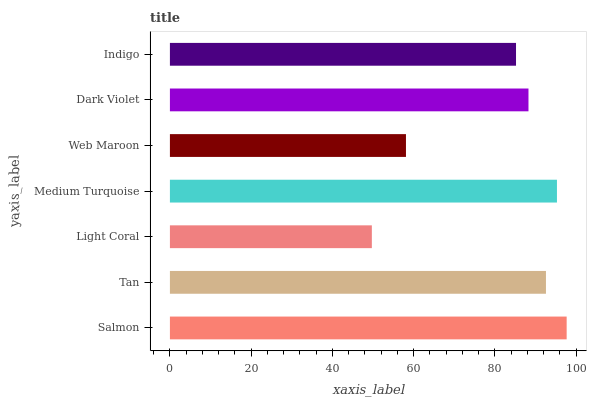Is Light Coral the minimum?
Answer yes or no. Yes. Is Salmon the maximum?
Answer yes or no. Yes. Is Tan the minimum?
Answer yes or no. No. Is Tan the maximum?
Answer yes or no. No. Is Salmon greater than Tan?
Answer yes or no. Yes. Is Tan less than Salmon?
Answer yes or no. Yes. Is Tan greater than Salmon?
Answer yes or no. No. Is Salmon less than Tan?
Answer yes or no. No. Is Dark Violet the high median?
Answer yes or no. Yes. Is Dark Violet the low median?
Answer yes or no. Yes. Is Salmon the high median?
Answer yes or no. No. Is Medium Turquoise the low median?
Answer yes or no. No. 